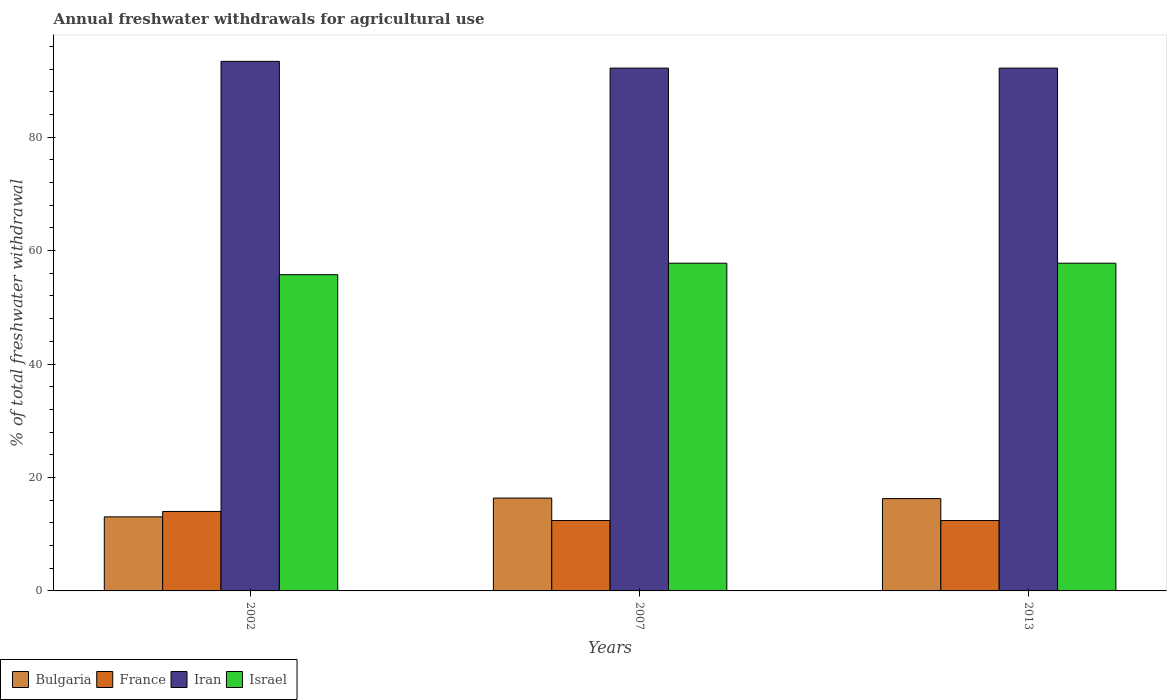How many bars are there on the 2nd tick from the right?
Give a very brief answer. 4. What is the label of the 3rd group of bars from the left?
Offer a very short reply. 2013. In how many cases, is the number of bars for a given year not equal to the number of legend labels?
Ensure brevity in your answer.  0. What is the total annual withdrawals from freshwater in Iran in 2002?
Keep it short and to the point. 93.37. Across all years, what is the maximum total annual withdrawals from freshwater in Bulgaria?
Make the answer very short. 16.37. Across all years, what is the minimum total annual withdrawals from freshwater in Bulgaria?
Make the answer very short. 13.06. In which year was the total annual withdrawals from freshwater in Bulgaria minimum?
Provide a short and direct response. 2002. What is the total total annual withdrawals from freshwater in France in the graph?
Give a very brief answer. 38.83. What is the difference between the total annual withdrawals from freshwater in Iran in 2002 and that in 2007?
Offer a very short reply. 1.19. What is the difference between the total annual withdrawals from freshwater in France in 2007 and the total annual withdrawals from freshwater in Israel in 2013?
Offer a terse response. -45.37. What is the average total annual withdrawals from freshwater in Bulgaria per year?
Provide a succinct answer. 15.24. In the year 2002, what is the difference between the total annual withdrawals from freshwater in Bulgaria and total annual withdrawals from freshwater in Israel?
Your response must be concise. -42.7. What is the ratio of the total annual withdrawals from freshwater in France in 2002 to that in 2007?
Provide a succinct answer. 1.13. What is the difference between the highest and the second highest total annual withdrawals from freshwater in France?
Your answer should be very brief. 1.6. What is the difference between the highest and the lowest total annual withdrawals from freshwater in Bulgaria?
Ensure brevity in your answer.  3.31. In how many years, is the total annual withdrawals from freshwater in France greater than the average total annual withdrawals from freshwater in France taken over all years?
Provide a succinct answer. 1. Is the sum of the total annual withdrawals from freshwater in France in 2002 and 2013 greater than the maximum total annual withdrawals from freshwater in Israel across all years?
Your answer should be very brief. No. Is it the case that in every year, the sum of the total annual withdrawals from freshwater in Iran and total annual withdrawals from freshwater in Bulgaria is greater than the sum of total annual withdrawals from freshwater in France and total annual withdrawals from freshwater in Israel?
Provide a succinct answer. No. What does the 2nd bar from the right in 2002 represents?
Your answer should be very brief. Iran. How many bars are there?
Your response must be concise. 12. Are all the bars in the graph horizontal?
Provide a succinct answer. No. How many years are there in the graph?
Offer a terse response. 3. What is the difference between two consecutive major ticks on the Y-axis?
Ensure brevity in your answer.  20. Does the graph contain any zero values?
Your response must be concise. No. Does the graph contain grids?
Provide a short and direct response. No. Where does the legend appear in the graph?
Your response must be concise. Bottom left. What is the title of the graph?
Offer a terse response. Annual freshwater withdrawals for agricultural use. What is the label or title of the Y-axis?
Ensure brevity in your answer.  % of total freshwater withdrawal. What is the % of total freshwater withdrawal of Bulgaria in 2002?
Offer a terse response. 13.06. What is the % of total freshwater withdrawal in France in 2002?
Give a very brief answer. 14.01. What is the % of total freshwater withdrawal of Iran in 2002?
Ensure brevity in your answer.  93.37. What is the % of total freshwater withdrawal of Israel in 2002?
Give a very brief answer. 55.76. What is the % of total freshwater withdrawal in Bulgaria in 2007?
Give a very brief answer. 16.37. What is the % of total freshwater withdrawal of France in 2007?
Offer a terse response. 12.41. What is the % of total freshwater withdrawal in Iran in 2007?
Keep it short and to the point. 92.18. What is the % of total freshwater withdrawal in Israel in 2007?
Make the answer very short. 57.78. What is the % of total freshwater withdrawal of Bulgaria in 2013?
Provide a short and direct response. 16.28. What is the % of total freshwater withdrawal of France in 2013?
Provide a short and direct response. 12.41. What is the % of total freshwater withdrawal of Iran in 2013?
Give a very brief answer. 92.18. What is the % of total freshwater withdrawal of Israel in 2013?
Your response must be concise. 57.78. Across all years, what is the maximum % of total freshwater withdrawal in Bulgaria?
Your answer should be very brief. 16.37. Across all years, what is the maximum % of total freshwater withdrawal in France?
Provide a short and direct response. 14.01. Across all years, what is the maximum % of total freshwater withdrawal of Iran?
Provide a succinct answer. 93.37. Across all years, what is the maximum % of total freshwater withdrawal in Israel?
Provide a succinct answer. 57.78. Across all years, what is the minimum % of total freshwater withdrawal of Bulgaria?
Offer a terse response. 13.06. Across all years, what is the minimum % of total freshwater withdrawal in France?
Make the answer very short. 12.41. Across all years, what is the minimum % of total freshwater withdrawal of Iran?
Provide a succinct answer. 92.18. Across all years, what is the minimum % of total freshwater withdrawal in Israel?
Provide a short and direct response. 55.76. What is the total % of total freshwater withdrawal in Bulgaria in the graph?
Offer a terse response. 45.71. What is the total % of total freshwater withdrawal in France in the graph?
Provide a succinct answer. 38.83. What is the total % of total freshwater withdrawal in Iran in the graph?
Your answer should be very brief. 277.73. What is the total % of total freshwater withdrawal in Israel in the graph?
Offer a very short reply. 171.32. What is the difference between the % of total freshwater withdrawal in Bulgaria in 2002 and that in 2007?
Offer a very short reply. -3.31. What is the difference between the % of total freshwater withdrawal of France in 2002 and that in 2007?
Your answer should be very brief. 1.6. What is the difference between the % of total freshwater withdrawal in Iran in 2002 and that in 2007?
Ensure brevity in your answer.  1.19. What is the difference between the % of total freshwater withdrawal in Israel in 2002 and that in 2007?
Make the answer very short. -2.02. What is the difference between the % of total freshwater withdrawal of Bulgaria in 2002 and that in 2013?
Ensure brevity in your answer.  -3.22. What is the difference between the % of total freshwater withdrawal of Iran in 2002 and that in 2013?
Provide a succinct answer. 1.19. What is the difference between the % of total freshwater withdrawal in Israel in 2002 and that in 2013?
Make the answer very short. -2.02. What is the difference between the % of total freshwater withdrawal in Bulgaria in 2007 and that in 2013?
Ensure brevity in your answer.  0.09. What is the difference between the % of total freshwater withdrawal of France in 2007 and that in 2013?
Your answer should be compact. 0. What is the difference between the % of total freshwater withdrawal in Iran in 2007 and that in 2013?
Offer a terse response. 0. What is the difference between the % of total freshwater withdrawal of Bulgaria in 2002 and the % of total freshwater withdrawal of France in 2007?
Give a very brief answer. 0.65. What is the difference between the % of total freshwater withdrawal in Bulgaria in 2002 and the % of total freshwater withdrawal in Iran in 2007?
Your answer should be compact. -79.12. What is the difference between the % of total freshwater withdrawal in Bulgaria in 2002 and the % of total freshwater withdrawal in Israel in 2007?
Ensure brevity in your answer.  -44.72. What is the difference between the % of total freshwater withdrawal in France in 2002 and the % of total freshwater withdrawal in Iran in 2007?
Offer a terse response. -78.17. What is the difference between the % of total freshwater withdrawal in France in 2002 and the % of total freshwater withdrawal in Israel in 2007?
Provide a short and direct response. -43.77. What is the difference between the % of total freshwater withdrawal of Iran in 2002 and the % of total freshwater withdrawal of Israel in 2007?
Offer a terse response. 35.59. What is the difference between the % of total freshwater withdrawal in Bulgaria in 2002 and the % of total freshwater withdrawal in France in 2013?
Keep it short and to the point. 0.65. What is the difference between the % of total freshwater withdrawal of Bulgaria in 2002 and the % of total freshwater withdrawal of Iran in 2013?
Keep it short and to the point. -79.12. What is the difference between the % of total freshwater withdrawal of Bulgaria in 2002 and the % of total freshwater withdrawal of Israel in 2013?
Keep it short and to the point. -44.72. What is the difference between the % of total freshwater withdrawal in France in 2002 and the % of total freshwater withdrawal in Iran in 2013?
Keep it short and to the point. -78.17. What is the difference between the % of total freshwater withdrawal of France in 2002 and the % of total freshwater withdrawal of Israel in 2013?
Provide a succinct answer. -43.77. What is the difference between the % of total freshwater withdrawal of Iran in 2002 and the % of total freshwater withdrawal of Israel in 2013?
Keep it short and to the point. 35.59. What is the difference between the % of total freshwater withdrawal in Bulgaria in 2007 and the % of total freshwater withdrawal in France in 2013?
Make the answer very short. 3.96. What is the difference between the % of total freshwater withdrawal in Bulgaria in 2007 and the % of total freshwater withdrawal in Iran in 2013?
Ensure brevity in your answer.  -75.81. What is the difference between the % of total freshwater withdrawal of Bulgaria in 2007 and the % of total freshwater withdrawal of Israel in 2013?
Offer a terse response. -41.41. What is the difference between the % of total freshwater withdrawal of France in 2007 and the % of total freshwater withdrawal of Iran in 2013?
Keep it short and to the point. -79.77. What is the difference between the % of total freshwater withdrawal of France in 2007 and the % of total freshwater withdrawal of Israel in 2013?
Make the answer very short. -45.37. What is the difference between the % of total freshwater withdrawal of Iran in 2007 and the % of total freshwater withdrawal of Israel in 2013?
Offer a very short reply. 34.4. What is the average % of total freshwater withdrawal of Bulgaria per year?
Keep it short and to the point. 15.24. What is the average % of total freshwater withdrawal in France per year?
Your answer should be compact. 12.94. What is the average % of total freshwater withdrawal of Iran per year?
Make the answer very short. 92.58. What is the average % of total freshwater withdrawal in Israel per year?
Keep it short and to the point. 57.11. In the year 2002, what is the difference between the % of total freshwater withdrawal in Bulgaria and % of total freshwater withdrawal in France?
Your answer should be very brief. -0.95. In the year 2002, what is the difference between the % of total freshwater withdrawal of Bulgaria and % of total freshwater withdrawal of Iran?
Offer a very short reply. -80.31. In the year 2002, what is the difference between the % of total freshwater withdrawal in Bulgaria and % of total freshwater withdrawal in Israel?
Ensure brevity in your answer.  -42.7. In the year 2002, what is the difference between the % of total freshwater withdrawal in France and % of total freshwater withdrawal in Iran?
Provide a succinct answer. -79.36. In the year 2002, what is the difference between the % of total freshwater withdrawal of France and % of total freshwater withdrawal of Israel?
Offer a terse response. -41.75. In the year 2002, what is the difference between the % of total freshwater withdrawal of Iran and % of total freshwater withdrawal of Israel?
Provide a succinct answer. 37.61. In the year 2007, what is the difference between the % of total freshwater withdrawal of Bulgaria and % of total freshwater withdrawal of France?
Your response must be concise. 3.96. In the year 2007, what is the difference between the % of total freshwater withdrawal in Bulgaria and % of total freshwater withdrawal in Iran?
Provide a short and direct response. -75.81. In the year 2007, what is the difference between the % of total freshwater withdrawal in Bulgaria and % of total freshwater withdrawal in Israel?
Your response must be concise. -41.41. In the year 2007, what is the difference between the % of total freshwater withdrawal of France and % of total freshwater withdrawal of Iran?
Ensure brevity in your answer.  -79.77. In the year 2007, what is the difference between the % of total freshwater withdrawal in France and % of total freshwater withdrawal in Israel?
Your response must be concise. -45.37. In the year 2007, what is the difference between the % of total freshwater withdrawal of Iran and % of total freshwater withdrawal of Israel?
Make the answer very short. 34.4. In the year 2013, what is the difference between the % of total freshwater withdrawal in Bulgaria and % of total freshwater withdrawal in France?
Make the answer very short. 3.87. In the year 2013, what is the difference between the % of total freshwater withdrawal of Bulgaria and % of total freshwater withdrawal of Iran?
Offer a very short reply. -75.9. In the year 2013, what is the difference between the % of total freshwater withdrawal in Bulgaria and % of total freshwater withdrawal in Israel?
Your answer should be very brief. -41.5. In the year 2013, what is the difference between the % of total freshwater withdrawal of France and % of total freshwater withdrawal of Iran?
Offer a terse response. -79.77. In the year 2013, what is the difference between the % of total freshwater withdrawal of France and % of total freshwater withdrawal of Israel?
Offer a terse response. -45.37. In the year 2013, what is the difference between the % of total freshwater withdrawal of Iran and % of total freshwater withdrawal of Israel?
Your response must be concise. 34.4. What is the ratio of the % of total freshwater withdrawal in Bulgaria in 2002 to that in 2007?
Keep it short and to the point. 0.8. What is the ratio of the % of total freshwater withdrawal in France in 2002 to that in 2007?
Offer a terse response. 1.13. What is the ratio of the % of total freshwater withdrawal of Iran in 2002 to that in 2007?
Your response must be concise. 1.01. What is the ratio of the % of total freshwater withdrawal of Israel in 2002 to that in 2007?
Offer a very short reply. 0.96. What is the ratio of the % of total freshwater withdrawal in Bulgaria in 2002 to that in 2013?
Provide a succinct answer. 0.8. What is the ratio of the % of total freshwater withdrawal of France in 2002 to that in 2013?
Your answer should be compact. 1.13. What is the ratio of the % of total freshwater withdrawal of Iran in 2002 to that in 2013?
Your response must be concise. 1.01. What is the ratio of the % of total freshwater withdrawal of Bulgaria in 2007 to that in 2013?
Make the answer very short. 1.01. What is the ratio of the % of total freshwater withdrawal in France in 2007 to that in 2013?
Give a very brief answer. 1. What is the ratio of the % of total freshwater withdrawal of Israel in 2007 to that in 2013?
Your answer should be compact. 1. What is the difference between the highest and the second highest % of total freshwater withdrawal in Bulgaria?
Offer a terse response. 0.09. What is the difference between the highest and the second highest % of total freshwater withdrawal of Iran?
Your response must be concise. 1.19. What is the difference between the highest and the lowest % of total freshwater withdrawal of Bulgaria?
Your response must be concise. 3.31. What is the difference between the highest and the lowest % of total freshwater withdrawal in France?
Keep it short and to the point. 1.6. What is the difference between the highest and the lowest % of total freshwater withdrawal in Iran?
Your answer should be compact. 1.19. What is the difference between the highest and the lowest % of total freshwater withdrawal in Israel?
Make the answer very short. 2.02. 